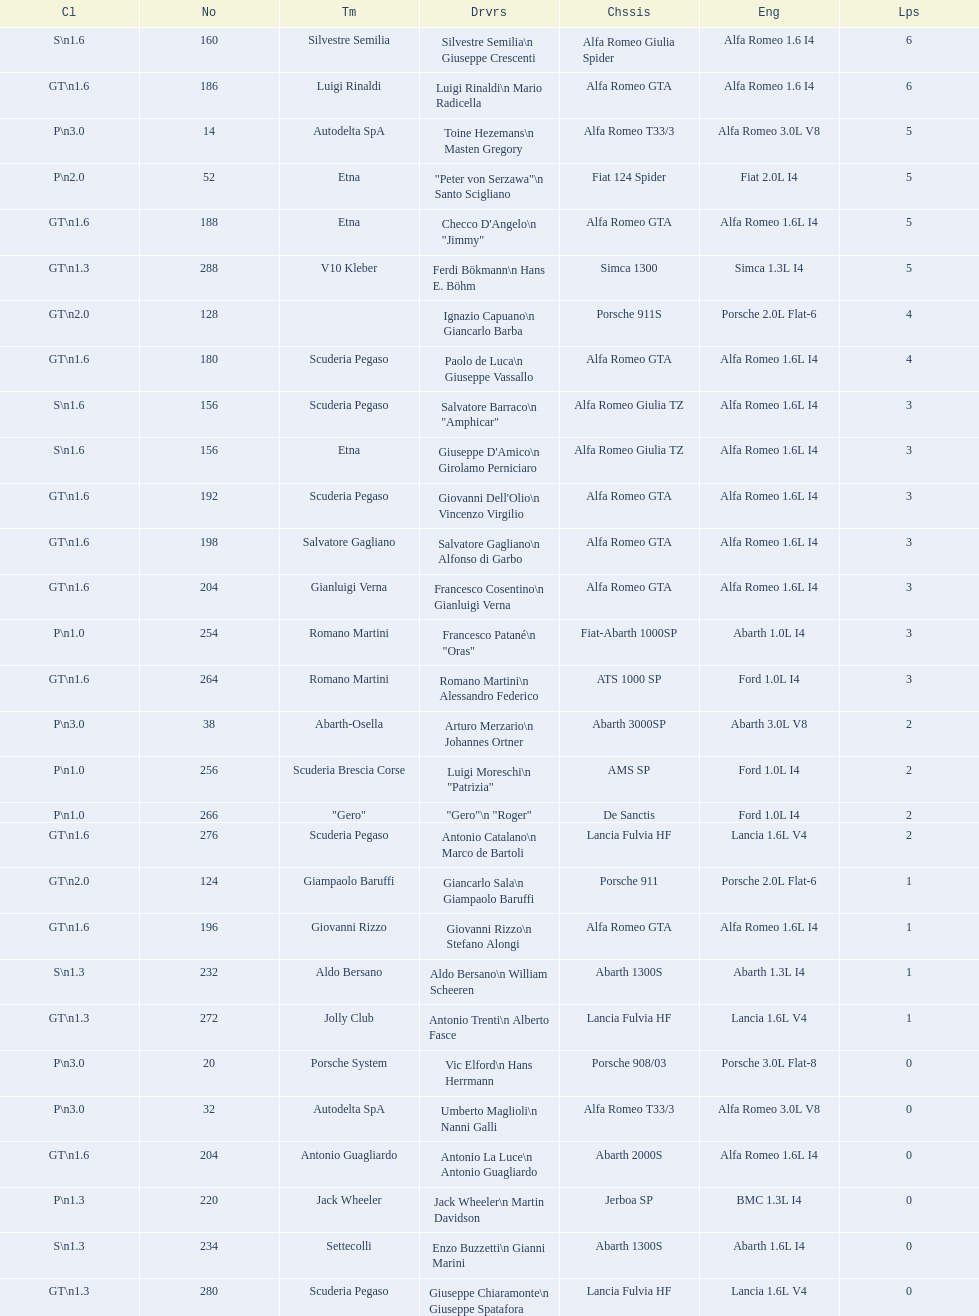His nickname is "jimmy," but what is his full name? Checco D'Angelo. 